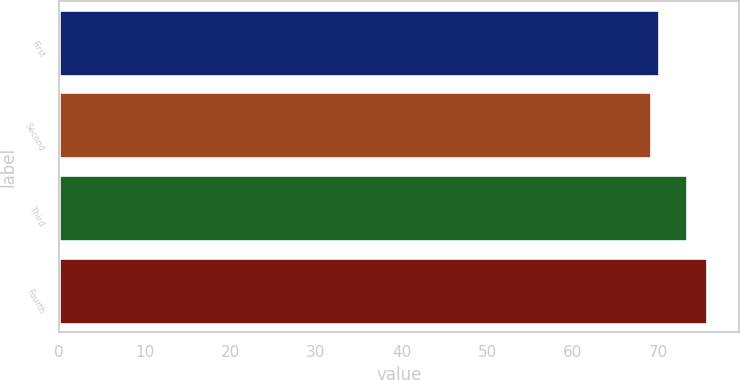<chart> <loc_0><loc_0><loc_500><loc_500><bar_chart><fcel>First<fcel>Second<fcel>Third<fcel>Fourth<nl><fcel>70.12<fcel>69.17<fcel>73.29<fcel>75.68<nl></chart> 